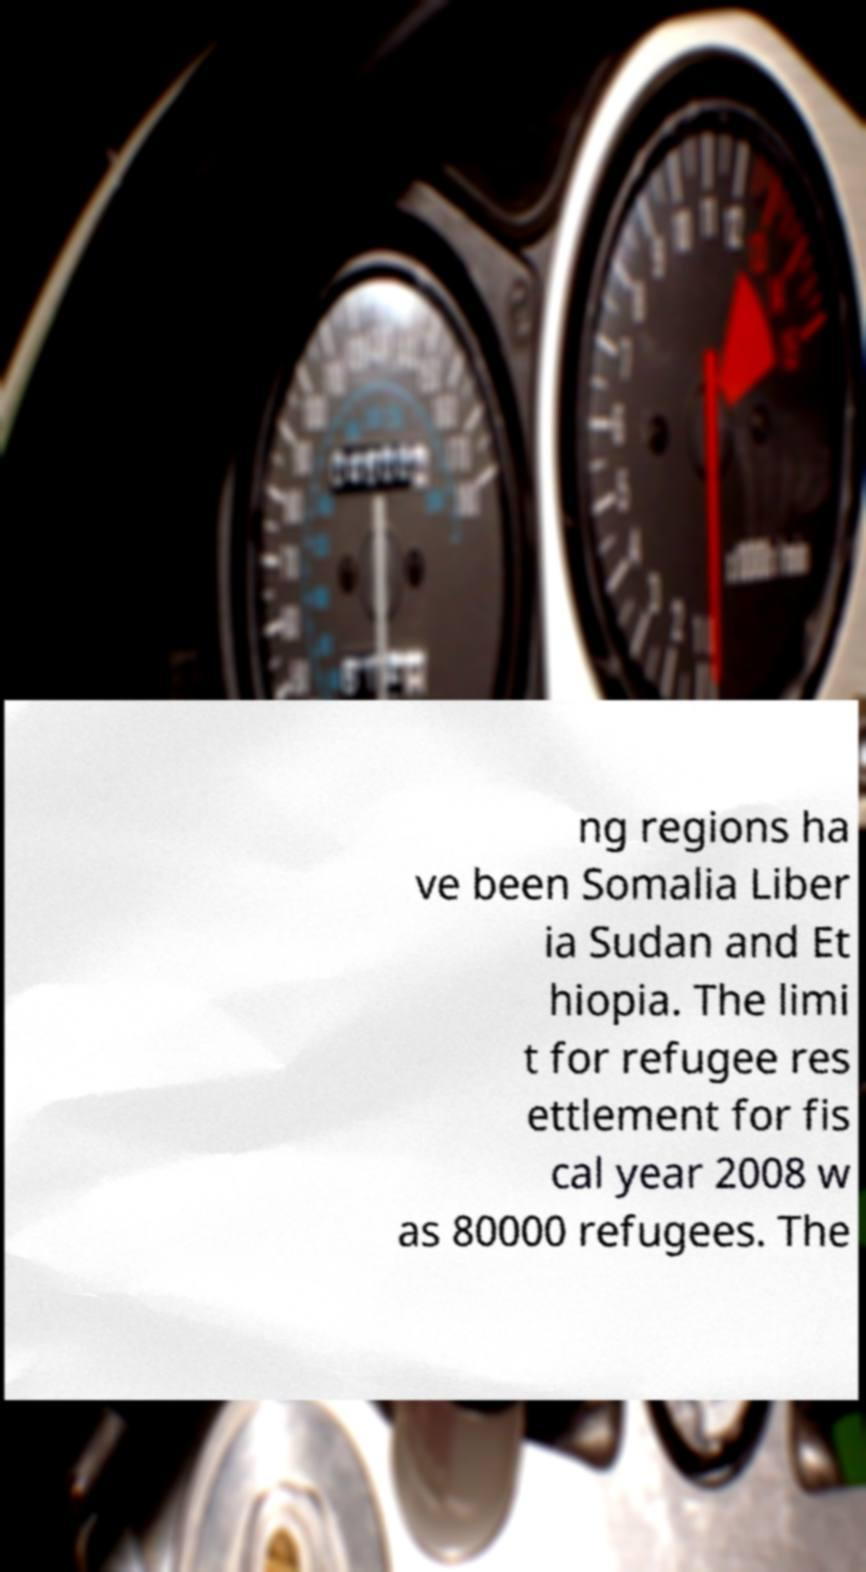I need the written content from this picture converted into text. Can you do that? ng regions ha ve been Somalia Liber ia Sudan and Et hiopia. The limi t for refugee res ettlement for fis cal year 2008 w as 80000 refugees. The 